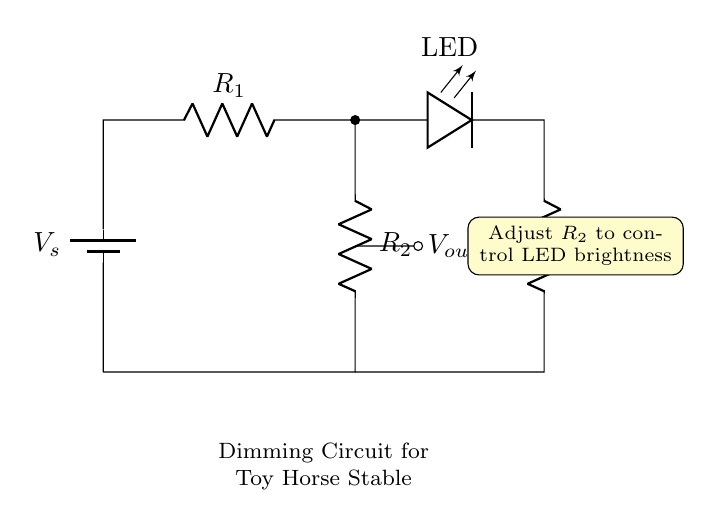What is the power source of the circuit? The power source is the battery, which provides the voltage for the circuit. In the diagram, it is represented as a battery symbol connected at the top.
Answer: Battery What does adjusting R2 do? Adjusting R2 changes the resistance in the circuit, which affects the output voltage at Vout and thus controls the brightness of the LED. This is explicitly stated in the note on the right side of the diagram.
Answer: Controls LED brightness How many resistors are there in this circuit? There are three resistors shown in the circuit diagram, identified as R1, R2, and R3. They are drawn as horizontal lines with labels next to them.
Answer: Three What is the output voltage symbol in this circuit? The output voltage is represented by the symbol Vout, which is directly connected between R2 and R3 in the circuit. This is indicated on the diagram beside a short connection marked with a dot.
Answer: Vout Which component is used to dim the LED? The resistor R2 is used to dim the LED by varying its resistance; therefore, it controls the voltage drop across R2 that affects how much current flows through the LED. This is detailed in the text box within the diagram.
Answer: R2 